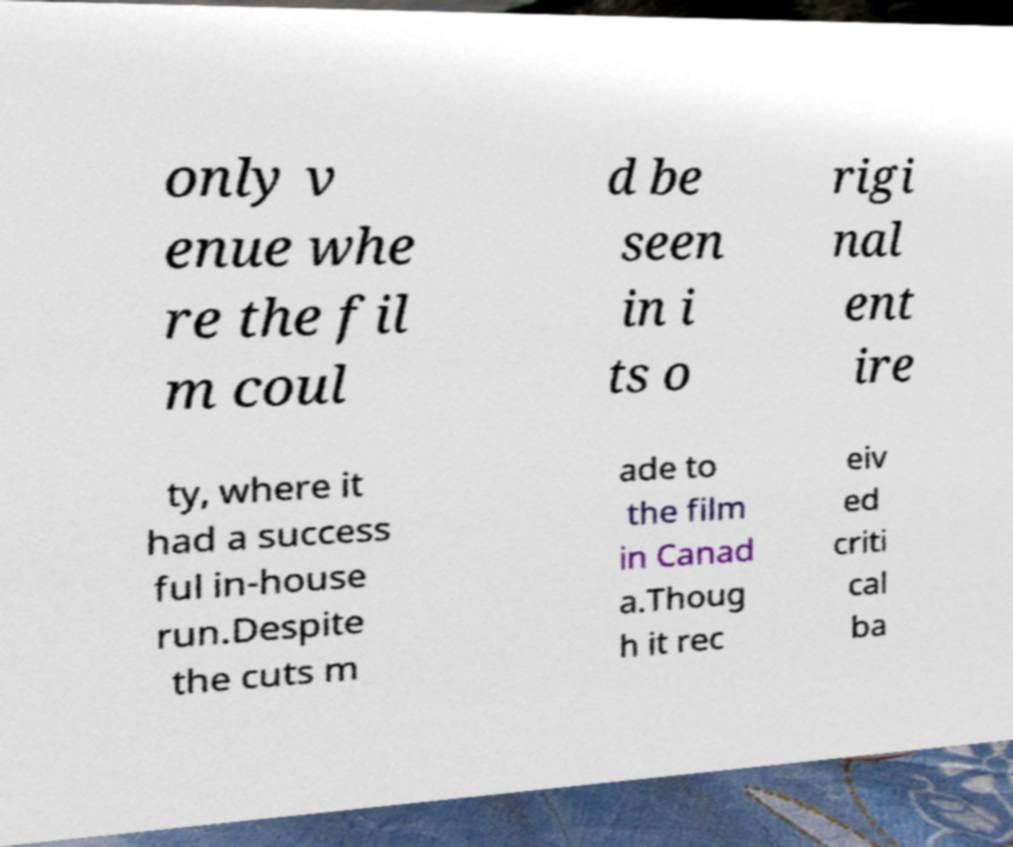Please identify and transcribe the text found in this image. only v enue whe re the fil m coul d be seen in i ts o rigi nal ent ire ty, where it had a success ful in-house run.Despite the cuts m ade to the film in Canad a.Thoug h it rec eiv ed criti cal ba 